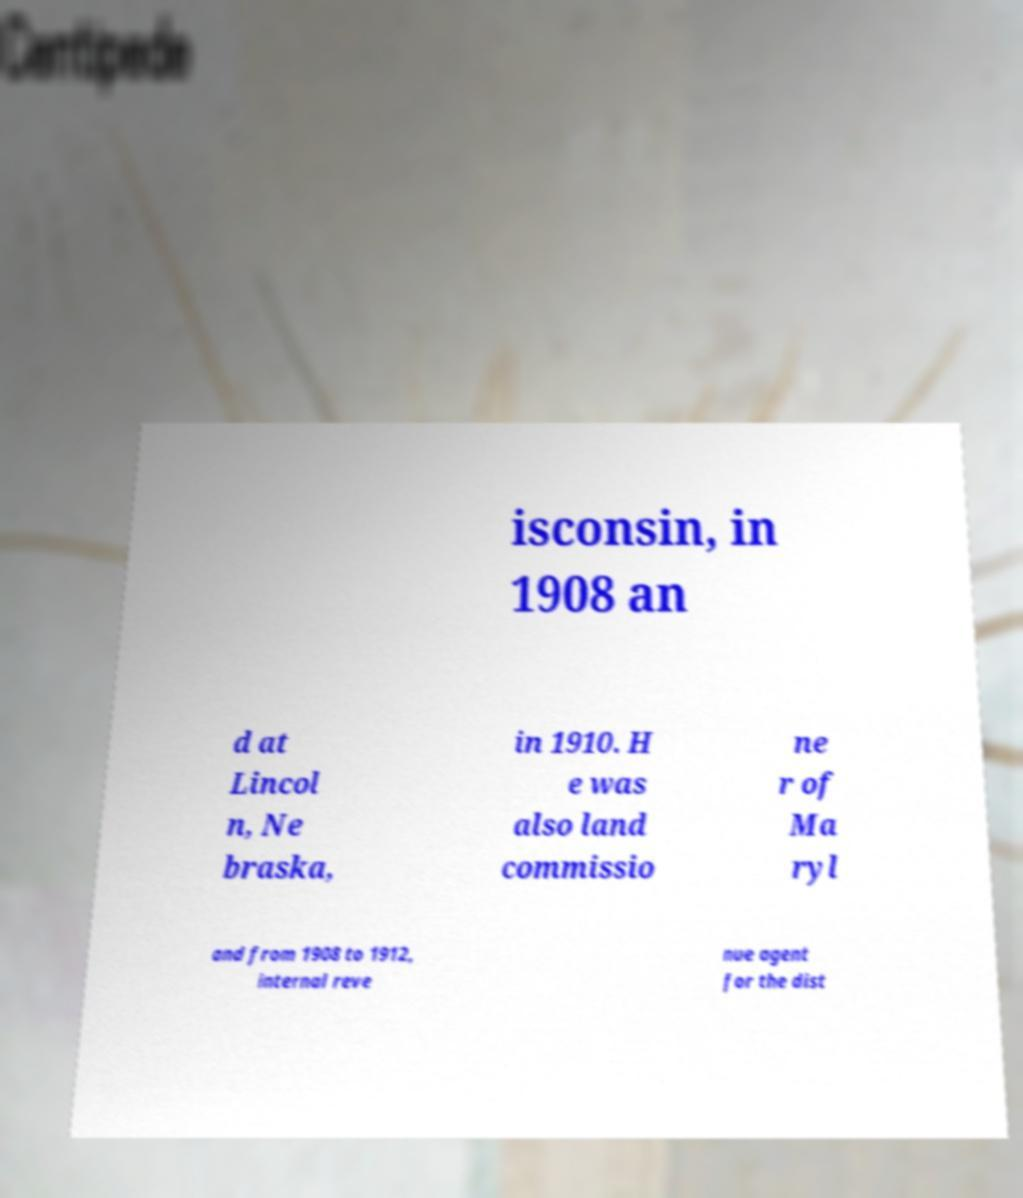Could you assist in decoding the text presented in this image and type it out clearly? isconsin, in 1908 an d at Lincol n, Ne braska, in 1910. H e was also land commissio ne r of Ma ryl and from 1908 to 1912, internal reve nue agent for the dist 